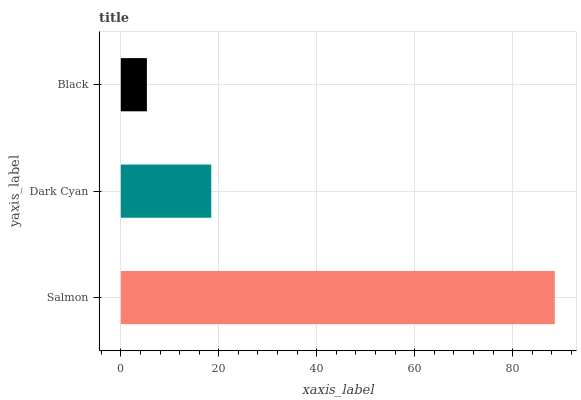Is Black the minimum?
Answer yes or no. Yes. Is Salmon the maximum?
Answer yes or no. Yes. Is Dark Cyan the minimum?
Answer yes or no. No. Is Dark Cyan the maximum?
Answer yes or no. No. Is Salmon greater than Dark Cyan?
Answer yes or no. Yes. Is Dark Cyan less than Salmon?
Answer yes or no. Yes. Is Dark Cyan greater than Salmon?
Answer yes or no. No. Is Salmon less than Dark Cyan?
Answer yes or no. No. Is Dark Cyan the high median?
Answer yes or no. Yes. Is Dark Cyan the low median?
Answer yes or no. Yes. Is Black the high median?
Answer yes or no. No. Is Salmon the low median?
Answer yes or no. No. 